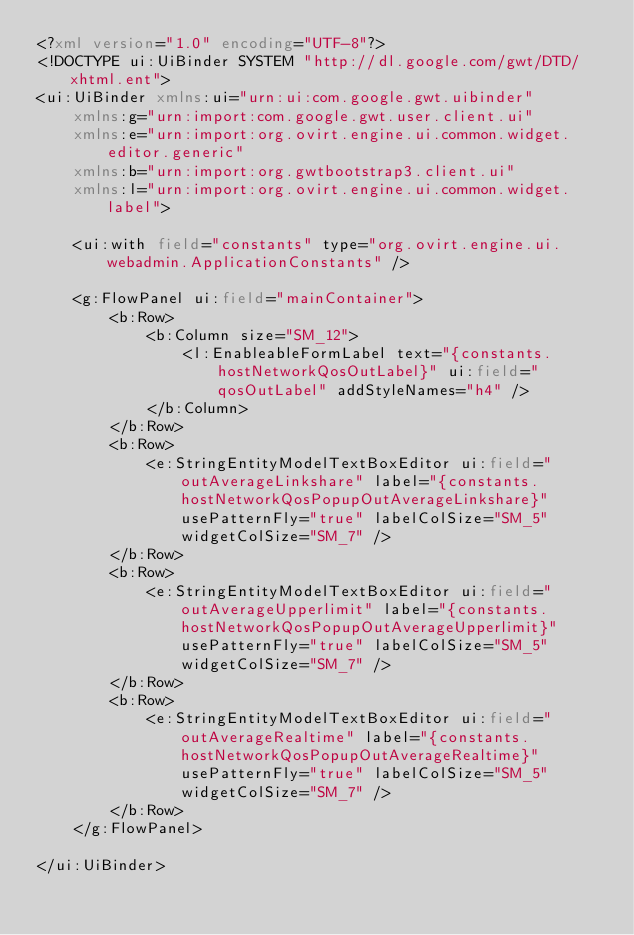<code> <loc_0><loc_0><loc_500><loc_500><_XML_><?xml version="1.0" encoding="UTF-8"?>
<!DOCTYPE ui:UiBinder SYSTEM "http://dl.google.com/gwt/DTD/xhtml.ent">
<ui:UiBinder xmlns:ui="urn:ui:com.google.gwt.uibinder"
    xmlns:g="urn:import:com.google.gwt.user.client.ui"
    xmlns:e="urn:import:org.ovirt.engine.ui.common.widget.editor.generic"
    xmlns:b="urn:import:org.gwtbootstrap3.client.ui"
    xmlns:l="urn:import:org.ovirt.engine.ui.common.widget.label">

    <ui:with field="constants" type="org.ovirt.engine.ui.webadmin.ApplicationConstants" />

    <g:FlowPanel ui:field="mainContainer">
        <b:Row>
            <b:Column size="SM_12">
                <l:EnableableFormLabel text="{constants.hostNetworkQosOutLabel}" ui:field="qosOutLabel" addStyleNames="h4" />
            </b:Column>
        </b:Row>
        <b:Row>
            <e:StringEntityModelTextBoxEditor ui:field="outAverageLinkshare" label="{constants.hostNetworkQosPopupOutAverageLinkshare}" usePatternFly="true" labelColSize="SM_5" widgetColSize="SM_7" />
        </b:Row>
        <b:Row>
            <e:StringEntityModelTextBoxEditor ui:field="outAverageUpperlimit" label="{constants.hostNetworkQosPopupOutAverageUpperlimit}" usePatternFly="true" labelColSize="SM_5" widgetColSize="SM_7" />
        </b:Row>
        <b:Row>
            <e:StringEntityModelTextBoxEditor ui:field="outAverageRealtime" label="{constants.hostNetworkQosPopupOutAverageRealtime}" usePatternFly="true" labelColSize="SM_5" widgetColSize="SM_7" />
        </b:Row>
    </g:FlowPanel>

</ui:UiBinder>
</code> 